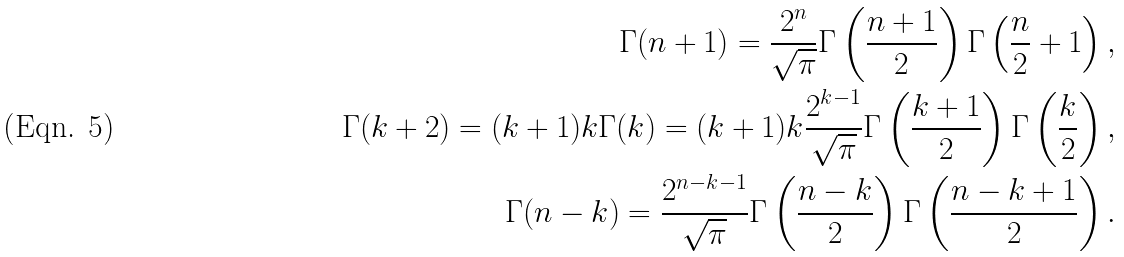Convert formula to latex. <formula><loc_0><loc_0><loc_500><loc_500>\Gamma ( n + 1 ) = \frac { 2 ^ { n } } { \sqrt { \pi } } \Gamma \left ( \frac { n + 1 } 2 \right ) \Gamma \left ( \frac { n } 2 + 1 \right ) , \\ \Gamma ( k + 2 ) = ( k + 1 ) k \Gamma ( k ) = ( k + 1 ) k \frac { 2 ^ { k - 1 } } { \sqrt { \pi } } \Gamma \left ( \frac { k + 1 } 2 \right ) \Gamma \left ( \frac { k } 2 \right ) , \\ \Gamma ( n - k ) = \frac { 2 ^ { n - k - 1 } } { \sqrt { \pi } } \Gamma \left ( \frac { n - k } 2 \right ) \Gamma \left ( \frac { n - k + 1 } 2 \right ) .</formula> 